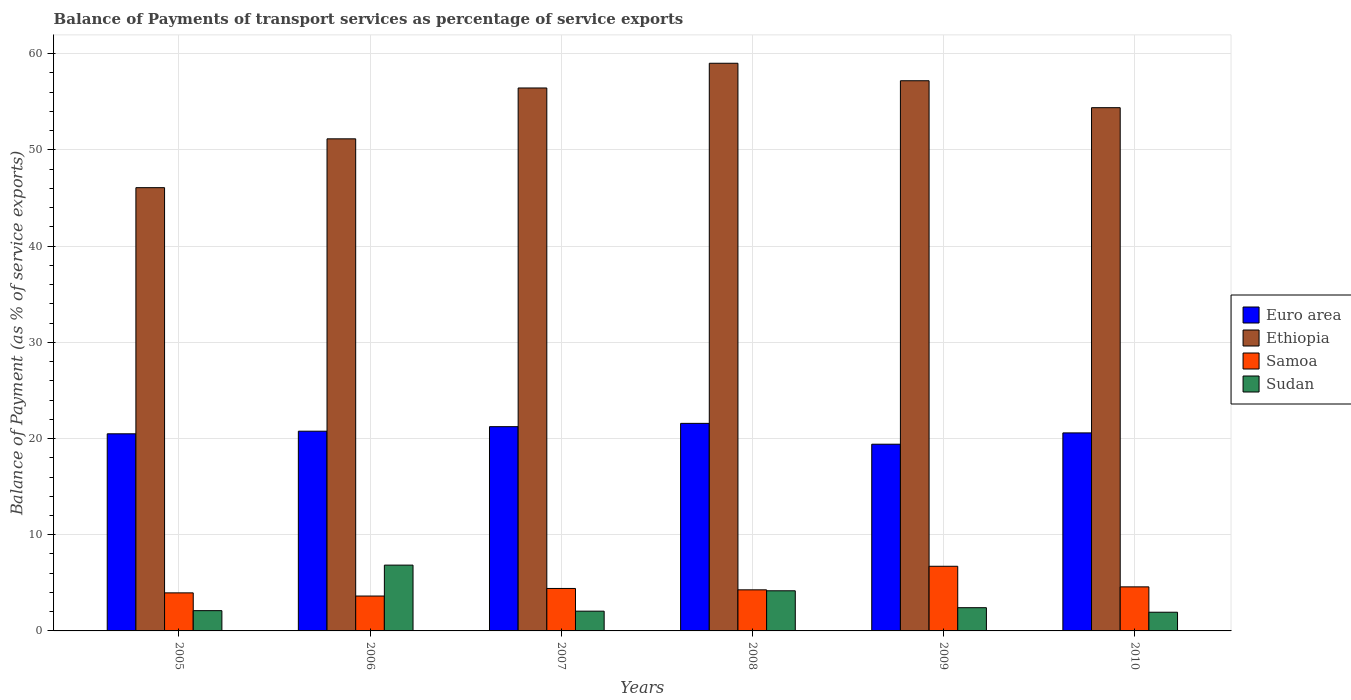Are the number of bars per tick equal to the number of legend labels?
Make the answer very short. Yes. Are the number of bars on each tick of the X-axis equal?
Offer a terse response. Yes. How many bars are there on the 3rd tick from the left?
Provide a succinct answer. 4. How many bars are there on the 1st tick from the right?
Offer a very short reply. 4. What is the label of the 2nd group of bars from the left?
Provide a short and direct response. 2006. What is the balance of payments of transport services in Sudan in 2010?
Your answer should be very brief. 1.94. Across all years, what is the maximum balance of payments of transport services in Sudan?
Provide a succinct answer. 6.84. Across all years, what is the minimum balance of payments of transport services in Ethiopia?
Your answer should be very brief. 46.08. What is the total balance of payments of transport services in Sudan in the graph?
Provide a succinct answer. 19.53. What is the difference between the balance of payments of transport services in Samoa in 2005 and that in 2009?
Give a very brief answer. -2.76. What is the difference between the balance of payments of transport services in Euro area in 2010 and the balance of payments of transport services in Samoa in 2005?
Make the answer very short. 16.63. What is the average balance of payments of transport services in Sudan per year?
Your answer should be compact. 3.26. In the year 2009, what is the difference between the balance of payments of transport services in Samoa and balance of payments of transport services in Ethiopia?
Your response must be concise. -50.47. In how many years, is the balance of payments of transport services in Samoa greater than 58 %?
Provide a short and direct response. 0. What is the ratio of the balance of payments of transport services in Euro area in 2006 to that in 2010?
Ensure brevity in your answer.  1.01. Is the difference between the balance of payments of transport services in Samoa in 2005 and 2009 greater than the difference between the balance of payments of transport services in Ethiopia in 2005 and 2009?
Provide a succinct answer. Yes. What is the difference between the highest and the second highest balance of payments of transport services in Euro area?
Your answer should be compact. 0.34. What is the difference between the highest and the lowest balance of payments of transport services in Samoa?
Provide a succinct answer. 3.09. Is it the case that in every year, the sum of the balance of payments of transport services in Ethiopia and balance of payments of transport services in Euro area is greater than the sum of balance of payments of transport services in Samoa and balance of payments of transport services in Sudan?
Offer a very short reply. No. What does the 1st bar from the left in 2007 represents?
Your answer should be compact. Euro area. What does the 3rd bar from the right in 2007 represents?
Give a very brief answer. Ethiopia. Is it the case that in every year, the sum of the balance of payments of transport services in Samoa and balance of payments of transport services in Sudan is greater than the balance of payments of transport services in Ethiopia?
Your response must be concise. No. Are all the bars in the graph horizontal?
Offer a terse response. No. How many years are there in the graph?
Your response must be concise. 6. Does the graph contain grids?
Give a very brief answer. Yes. Where does the legend appear in the graph?
Your answer should be very brief. Center right. How many legend labels are there?
Give a very brief answer. 4. What is the title of the graph?
Offer a very short reply. Balance of Payments of transport services as percentage of service exports. Does "Somalia" appear as one of the legend labels in the graph?
Provide a short and direct response. No. What is the label or title of the X-axis?
Make the answer very short. Years. What is the label or title of the Y-axis?
Provide a short and direct response. Balance of Payment (as % of service exports). What is the Balance of Payment (as % of service exports) of Euro area in 2005?
Offer a very short reply. 20.49. What is the Balance of Payment (as % of service exports) in Ethiopia in 2005?
Offer a terse response. 46.08. What is the Balance of Payment (as % of service exports) in Samoa in 2005?
Offer a very short reply. 3.96. What is the Balance of Payment (as % of service exports) in Sudan in 2005?
Provide a succinct answer. 2.11. What is the Balance of Payment (as % of service exports) in Euro area in 2006?
Make the answer very short. 20.76. What is the Balance of Payment (as % of service exports) in Ethiopia in 2006?
Give a very brief answer. 51.16. What is the Balance of Payment (as % of service exports) of Samoa in 2006?
Give a very brief answer. 3.63. What is the Balance of Payment (as % of service exports) of Sudan in 2006?
Offer a very short reply. 6.84. What is the Balance of Payment (as % of service exports) of Euro area in 2007?
Provide a succinct answer. 21.23. What is the Balance of Payment (as % of service exports) in Ethiopia in 2007?
Keep it short and to the point. 56.44. What is the Balance of Payment (as % of service exports) of Samoa in 2007?
Your response must be concise. 4.41. What is the Balance of Payment (as % of service exports) in Sudan in 2007?
Offer a terse response. 2.05. What is the Balance of Payment (as % of service exports) in Euro area in 2008?
Offer a terse response. 21.58. What is the Balance of Payment (as % of service exports) in Ethiopia in 2008?
Provide a short and direct response. 59.01. What is the Balance of Payment (as % of service exports) in Samoa in 2008?
Keep it short and to the point. 4.27. What is the Balance of Payment (as % of service exports) in Sudan in 2008?
Your answer should be very brief. 4.17. What is the Balance of Payment (as % of service exports) of Euro area in 2009?
Offer a very short reply. 19.41. What is the Balance of Payment (as % of service exports) of Ethiopia in 2009?
Make the answer very short. 57.19. What is the Balance of Payment (as % of service exports) in Samoa in 2009?
Your answer should be very brief. 6.72. What is the Balance of Payment (as % of service exports) in Sudan in 2009?
Give a very brief answer. 2.41. What is the Balance of Payment (as % of service exports) of Euro area in 2010?
Your answer should be very brief. 20.59. What is the Balance of Payment (as % of service exports) in Ethiopia in 2010?
Provide a succinct answer. 54.39. What is the Balance of Payment (as % of service exports) of Samoa in 2010?
Provide a succinct answer. 4.58. What is the Balance of Payment (as % of service exports) of Sudan in 2010?
Offer a very short reply. 1.94. Across all years, what is the maximum Balance of Payment (as % of service exports) of Euro area?
Offer a very short reply. 21.58. Across all years, what is the maximum Balance of Payment (as % of service exports) of Ethiopia?
Make the answer very short. 59.01. Across all years, what is the maximum Balance of Payment (as % of service exports) in Samoa?
Give a very brief answer. 6.72. Across all years, what is the maximum Balance of Payment (as % of service exports) in Sudan?
Offer a terse response. 6.84. Across all years, what is the minimum Balance of Payment (as % of service exports) of Euro area?
Make the answer very short. 19.41. Across all years, what is the minimum Balance of Payment (as % of service exports) in Ethiopia?
Keep it short and to the point. 46.08. Across all years, what is the minimum Balance of Payment (as % of service exports) of Samoa?
Offer a terse response. 3.63. Across all years, what is the minimum Balance of Payment (as % of service exports) in Sudan?
Your answer should be compact. 1.94. What is the total Balance of Payment (as % of service exports) in Euro area in the graph?
Your answer should be compact. 124.06. What is the total Balance of Payment (as % of service exports) of Ethiopia in the graph?
Provide a succinct answer. 324.28. What is the total Balance of Payment (as % of service exports) in Samoa in the graph?
Keep it short and to the point. 27.57. What is the total Balance of Payment (as % of service exports) of Sudan in the graph?
Give a very brief answer. 19.53. What is the difference between the Balance of Payment (as % of service exports) in Euro area in 2005 and that in 2006?
Offer a terse response. -0.27. What is the difference between the Balance of Payment (as % of service exports) in Ethiopia in 2005 and that in 2006?
Ensure brevity in your answer.  -5.08. What is the difference between the Balance of Payment (as % of service exports) in Samoa in 2005 and that in 2006?
Offer a terse response. 0.33. What is the difference between the Balance of Payment (as % of service exports) of Sudan in 2005 and that in 2006?
Offer a terse response. -4.73. What is the difference between the Balance of Payment (as % of service exports) in Euro area in 2005 and that in 2007?
Your response must be concise. -0.74. What is the difference between the Balance of Payment (as % of service exports) in Ethiopia in 2005 and that in 2007?
Provide a short and direct response. -10.36. What is the difference between the Balance of Payment (as % of service exports) of Samoa in 2005 and that in 2007?
Your response must be concise. -0.46. What is the difference between the Balance of Payment (as % of service exports) of Sudan in 2005 and that in 2007?
Provide a succinct answer. 0.05. What is the difference between the Balance of Payment (as % of service exports) in Euro area in 2005 and that in 2008?
Give a very brief answer. -1.09. What is the difference between the Balance of Payment (as % of service exports) of Ethiopia in 2005 and that in 2008?
Provide a succinct answer. -12.93. What is the difference between the Balance of Payment (as % of service exports) of Samoa in 2005 and that in 2008?
Give a very brief answer. -0.32. What is the difference between the Balance of Payment (as % of service exports) in Sudan in 2005 and that in 2008?
Provide a short and direct response. -2.07. What is the difference between the Balance of Payment (as % of service exports) in Euro area in 2005 and that in 2009?
Your answer should be compact. 1.08. What is the difference between the Balance of Payment (as % of service exports) of Ethiopia in 2005 and that in 2009?
Your answer should be compact. -11.12. What is the difference between the Balance of Payment (as % of service exports) in Samoa in 2005 and that in 2009?
Your response must be concise. -2.76. What is the difference between the Balance of Payment (as % of service exports) of Sudan in 2005 and that in 2009?
Your answer should be very brief. -0.31. What is the difference between the Balance of Payment (as % of service exports) of Euro area in 2005 and that in 2010?
Provide a short and direct response. -0.09. What is the difference between the Balance of Payment (as % of service exports) in Ethiopia in 2005 and that in 2010?
Provide a succinct answer. -8.31. What is the difference between the Balance of Payment (as % of service exports) of Samoa in 2005 and that in 2010?
Your answer should be very brief. -0.62. What is the difference between the Balance of Payment (as % of service exports) in Sudan in 2005 and that in 2010?
Provide a succinct answer. 0.16. What is the difference between the Balance of Payment (as % of service exports) in Euro area in 2006 and that in 2007?
Offer a terse response. -0.47. What is the difference between the Balance of Payment (as % of service exports) in Ethiopia in 2006 and that in 2007?
Ensure brevity in your answer.  -5.29. What is the difference between the Balance of Payment (as % of service exports) of Samoa in 2006 and that in 2007?
Your response must be concise. -0.79. What is the difference between the Balance of Payment (as % of service exports) of Sudan in 2006 and that in 2007?
Offer a very short reply. 4.79. What is the difference between the Balance of Payment (as % of service exports) of Euro area in 2006 and that in 2008?
Give a very brief answer. -0.81. What is the difference between the Balance of Payment (as % of service exports) in Ethiopia in 2006 and that in 2008?
Keep it short and to the point. -7.86. What is the difference between the Balance of Payment (as % of service exports) in Samoa in 2006 and that in 2008?
Provide a short and direct response. -0.65. What is the difference between the Balance of Payment (as % of service exports) in Sudan in 2006 and that in 2008?
Provide a succinct answer. 2.67. What is the difference between the Balance of Payment (as % of service exports) in Euro area in 2006 and that in 2009?
Make the answer very short. 1.35. What is the difference between the Balance of Payment (as % of service exports) of Ethiopia in 2006 and that in 2009?
Your answer should be very brief. -6.04. What is the difference between the Balance of Payment (as % of service exports) of Samoa in 2006 and that in 2009?
Your response must be concise. -3.09. What is the difference between the Balance of Payment (as % of service exports) in Sudan in 2006 and that in 2009?
Keep it short and to the point. 4.43. What is the difference between the Balance of Payment (as % of service exports) of Euro area in 2006 and that in 2010?
Provide a short and direct response. 0.18. What is the difference between the Balance of Payment (as % of service exports) in Ethiopia in 2006 and that in 2010?
Provide a short and direct response. -3.24. What is the difference between the Balance of Payment (as % of service exports) in Samoa in 2006 and that in 2010?
Provide a succinct answer. -0.95. What is the difference between the Balance of Payment (as % of service exports) in Sudan in 2006 and that in 2010?
Provide a short and direct response. 4.9. What is the difference between the Balance of Payment (as % of service exports) of Euro area in 2007 and that in 2008?
Ensure brevity in your answer.  -0.34. What is the difference between the Balance of Payment (as % of service exports) in Ethiopia in 2007 and that in 2008?
Offer a very short reply. -2.57. What is the difference between the Balance of Payment (as % of service exports) of Samoa in 2007 and that in 2008?
Provide a short and direct response. 0.14. What is the difference between the Balance of Payment (as % of service exports) of Sudan in 2007 and that in 2008?
Your answer should be very brief. -2.12. What is the difference between the Balance of Payment (as % of service exports) of Euro area in 2007 and that in 2009?
Provide a succinct answer. 1.82. What is the difference between the Balance of Payment (as % of service exports) in Ethiopia in 2007 and that in 2009?
Provide a short and direct response. -0.75. What is the difference between the Balance of Payment (as % of service exports) in Samoa in 2007 and that in 2009?
Provide a succinct answer. -2.31. What is the difference between the Balance of Payment (as % of service exports) of Sudan in 2007 and that in 2009?
Offer a very short reply. -0.36. What is the difference between the Balance of Payment (as % of service exports) in Euro area in 2007 and that in 2010?
Make the answer very short. 0.65. What is the difference between the Balance of Payment (as % of service exports) of Ethiopia in 2007 and that in 2010?
Ensure brevity in your answer.  2.05. What is the difference between the Balance of Payment (as % of service exports) of Samoa in 2007 and that in 2010?
Provide a short and direct response. -0.17. What is the difference between the Balance of Payment (as % of service exports) in Sudan in 2007 and that in 2010?
Keep it short and to the point. 0.11. What is the difference between the Balance of Payment (as % of service exports) of Euro area in 2008 and that in 2009?
Provide a succinct answer. 2.17. What is the difference between the Balance of Payment (as % of service exports) in Ethiopia in 2008 and that in 2009?
Keep it short and to the point. 1.82. What is the difference between the Balance of Payment (as % of service exports) in Samoa in 2008 and that in 2009?
Keep it short and to the point. -2.45. What is the difference between the Balance of Payment (as % of service exports) of Sudan in 2008 and that in 2009?
Offer a very short reply. 1.76. What is the difference between the Balance of Payment (as % of service exports) in Euro area in 2008 and that in 2010?
Offer a terse response. 0.99. What is the difference between the Balance of Payment (as % of service exports) in Ethiopia in 2008 and that in 2010?
Your answer should be very brief. 4.62. What is the difference between the Balance of Payment (as % of service exports) in Samoa in 2008 and that in 2010?
Give a very brief answer. -0.31. What is the difference between the Balance of Payment (as % of service exports) in Sudan in 2008 and that in 2010?
Your answer should be compact. 2.23. What is the difference between the Balance of Payment (as % of service exports) in Euro area in 2009 and that in 2010?
Your answer should be very brief. -1.18. What is the difference between the Balance of Payment (as % of service exports) of Ethiopia in 2009 and that in 2010?
Ensure brevity in your answer.  2.8. What is the difference between the Balance of Payment (as % of service exports) of Samoa in 2009 and that in 2010?
Your response must be concise. 2.14. What is the difference between the Balance of Payment (as % of service exports) of Sudan in 2009 and that in 2010?
Make the answer very short. 0.47. What is the difference between the Balance of Payment (as % of service exports) in Euro area in 2005 and the Balance of Payment (as % of service exports) in Ethiopia in 2006?
Offer a terse response. -30.66. What is the difference between the Balance of Payment (as % of service exports) in Euro area in 2005 and the Balance of Payment (as % of service exports) in Samoa in 2006?
Provide a short and direct response. 16.87. What is the difference between the Balance of Payment (as % of service exports) of Euro area in 2005 and the Balance of Payment (as % of service exports) of Sudan in 2006?
Your response must be concise. 13.65. What is the difference between the Balance of Payment (as % of service exports) of Ethiopia in 2005 and the Balance of Payment (as % of service exports) of Samoa in 2006?
Ensure brevity in your answer.  42.45. What is the difference between the Balance of Payment (as % of service exports) of Ethiopia in 2005 and the Balance of Payment (as % of service exports) of Sudan in 2006?
Offer a very short reply. 39.24. What is the difference between the Balance of Payment (as % of service exports) of Samoa in 2005 and the Balance of Payment (as % of service exports) of Sudan in 2006?
Make the answer very short. -2.88. What is the difference between the Balance of Payment (as % of service exports) of Euro area in 2005 and the Balance of Payment (as % of service exports) of Ethiopia in 2007?
Your answer should be very brief. -35.95. What is the difference between the Balance of Payment (as % of service exports) of Euro area in 2005 and the Balance of Payment (as % of service exports) of Samoa in 2007?
Offer a very short reply. 16.08. What is the difference between the Balance of Payment (as % of service exports) in Euro area in 2005 and the Balance of Payment (as % of service exports) in Sudan in 2007?
Your response must be concise. 18.44. What is the difference between the Balance of Payment (as % of service exports) of Ethiopia in 2005 and the Balance of Payment (as % of service exports) of Samoa in 2007?
Provide a short and direct response. 41.67. What is the difference between the Balance of Payment (as % of service exports) of Ethiopia in 2005 and the Balance of Payment (as % of service exports) of Sudan in 2007?
Your response must be concise. 44.03. What is the difference between the Balance of Payment (as % of service exports) in Samoa in 2005 and the Balance of Payment (as % of service exports) in Sudan in 2007?
Offer a terse response. 1.9. What is the difference between the Balance of Payment (as % of service exports) in Euro area in 2005 and the Balance of Payment (as % of service exports) in Ethiopia in 2008?
Keep it short and to the point. -38.52. What is the difference between the Balance of Payment (as % of service exports) of Euro area in 2005 and the Balance of Payment (as % of service exports) of Samoa in 2008?
Keep it short and to the point. 16.22. What is the difference between the Balance of Payment (as % of service exports) in Euro area in 2005 and the Balance of Payment (as % of service exports) in Sudan in 2008?
Your response must be concise. 16.32. What is the difference between the Balance of Payment (as % of service exports) of Ethiopia in 2005 and the Balance of Payment (as % of service exports) of Samoa in 2008?
Make the answer very short. 41.81. What is the difference between the Balance of Payment (as % of service exports) of Ethiopia in 2005 and the Balance of Payment (as % of service exports) of Sudan in 2008?
Make the answer very short. 41.91. What is the difference between the Balance of Payment (as % of service exports) of Samoa in 2005 and the Balance of Payment (as % of service exports) of Sudan in 2008?
Your answer should be compact. -0.22. What is the difference between the Balance of Payment (as % of service exports) of Euro area in 2005 and the Balance of Payment (as % of service exports) of Ethiopia in 2009?
Make the answer very short. -36.7. What is the difference between the Balance of Payment (as % of service exports) in Euro area in 2005 and the Balance of Payment (as % of service exports) in Samoa in 2009?
Keep it short and to the point. 13.77. What is the difference between the Balance of Payment (as % of service exports) in Euro area in 2005 and the Balance of Payment (as % of service exports) in Sudan in 2009?
Ensure brevity in your answer.  18.08. What is the difference between the Balance of Payment (as % of service exports) of Ethiopia in 2005 and the Balance of Payment (as % of service exports) of Samoa in 2009?
Provide a short and direct response. 39.36. What is the difference between the Balance of Payment (as % of service exports) of Ethiopia in 2005 and the Balance of Payment (as % of service exports) of Sudan in 2009?
Ensure brevity in your answer.  43.66. What is the difference between the Balance of Payment (as % of service exports) in Samoa in 2005 and the Balance of Payment (as % of service exports) in Sudan in 2009?
Provide a short and direct response. 1.54. What is the difference between the Balance of Payment (as % of service exports) in Euro area in 2005 and the Balance of Payment (as % of service exports) in Ethiopia in 2010?
Give a very brief answer. -33.9. What is the difference between the Balance of Payment (as % of service exports) in Euro area in 2005 and the Balance of Payment (as % of service exports) in Samoa in 2010?
Offer a very short reply. 15.91. What is the difference between the Balance of Payment (as % of service exports) of Euro area in 2005 and the Balance of Payment (as % of service exports) of Sudan in 2010?
Give a very brief answer. 18.55. What is the difference between the Balance of Payment (as % of service exports) in Ethiopia in 2005 and the Balance of Payment (as % of service exports) in Samoa in 2010?
Provide a short and direct response. 41.5. What is the difference between the Balance of Payment (as % of service exports) in Ethiopia in 2005 and the Balance of Payment (as % of service exports) in Sudan in 2010?
Make the answer very short. 44.14. What is the difference between the Balance of Payment (as % of service exports) of Samoa in 2005 and the Balance of Payment (as % of service exports) of Sudan in 2010?
Provide a short and direct response. 2.01. What is the difference between the Balance of Payment (as % of service exports) in Euro area in 2006 and the Balance of Payment (as % of service exports) in Ethiopia in 2007?
Make the answer very short. -35.68. What is the difference between the Balance of Payment (as % of service exports) in Euro area in 2006 and the Balance of Payment (as % of service exports) in Samoa in 2007?
Give a very brief answer. 16.35. What is the difference between the Balance of Payment (as % of service exports) in Euro area in 2006 and the Balance of Payment (as % of service exports) in Sudan in 2007?
Ensure brevity in your answer.  18.71. What is the difference between the Balance of Payment (as % of service exports) of Ethiopia in 2006 and the Balance of Payment (as % of service exports) of Samoa in 2007?
Make the answer very short. 46.74. What is the difference between the Balance of Payment (as % of service exports) in Ethiopia in 2006 and the Balance of Payment (as % of service exports) in Sudan in 2007?
Offer a terse response. 49.1. What is the difference between the Balance of Payment (as % of service exports) in Samoa in 2006 and the Balance of Payment (as % of service exports) in Sudan in 2007?
Your answer should be compact. 1.57. What is the difference between the Balance of Payment (as % of service exports) of Euro area in 2006 and the Balance of Payment (as % of service exports) of Ethiopia in 2008?
Make the answer very short. -38.25. What is the difference between the Balance of Payment (as % of service exports) of Euro area in 2006 and the Balance of Payment (as % of service exports) of Samoa in 2008?
Your answer should be very brief. 16.49. What is the difference between the Balance of Payment (as % of service exports) of Euro area in 2006 and the Balance of Payment (as % of service exports) of Sudan in 2008?
Your answer should be very brief. 16.59. What is the difference between the Balance of Payment (as % of service exports) of Ethiopia in 2006 and the Balance of Payment (as % of service exports) of Samoa in 2008?
Ensure brevity in your answer.  46.88. What is the difference between the Balance of Payment (as % of service exports) in Ethiopia in 2006 and the Balance of Payment (as % of service exports) in Sudan in 2008?
Make the answer very short. 46.98. What is the difference between the Balance of Payment (as % of service exports) of Samoa in 2006 and the Balance of Payment (as % of service exports) of Sudan in 2008?
Ensure brevity in your answer.  -0.55. What is the difference between the Balance of Payment (as % of service exports) of Euro area in 2006 and the Balance of Payment (as % of service exports) of Ethiopia in 2009?
Make the answer very short. -36.43. What is the difference between the Balance of Payment (as % of service exports) in Euro area in 2006 and the Balance of Payment (as % of service exports) in Samoa in 2009?
Provide a succinct answer. 14.04. What is the difference between the Balance of Payment (as % of service exports) of Euro area in 2006 and the Balance of Payment (as % of service exports) of Sudan in 2009?
Give a very brief answer. 18.35. What is the difference between the Balance of Payment (as % of service exports) of Ethiopia in 2006 and the Balance of Payment (as % of service exports) of Samoa in 2009?
Your answer should be compact. 44.44. What is the difference between the Balance of Payment (as % of service exports) in Ethiopia in 2006 and the Balance of Payment (as % of service exports) in Sudan in 2009?
Give a very brief answer. 48.74. What is the difference between the Balance of Payment (as % of service exports) of Samoa in 2006 and the Balance of Payment (as % of service exports) of Sudan in 2009?
Give a very brief answer. 1.21. What is the difference between the Balance of Payment (as % of service exports) in Euro area in 2006 and the Balance of Payment (as % of service exports) in Ethiopia in 2010?
Make the answer very short. -33.63. What is the difference between the Balance of Payment (as % of service exports) in Euro area in 2006 and the Balance of Payment (as % of service exports) in Samoa in 2010?
Your response must be concise. 16.18. What is the difference between the Balance of Payment (as % of service exports) in Euro area in 2006 and the Balance of Payment (as % of service exports) in Sudan in 2010?
Make the answer very short. 18.82. What is the difference between the Balance of Payment (as % of service exports) in Ethiopia in 2006 and the Balance of Payment (as % of service exports) in Samoa in 2010?
Your answer should be very brief. 46.58. What is the difference between the Balance of Payment (as % of service exports) of Ethiopia in 2006 and the Balance of Payment (as % of service exports) of Sudan in 2010?
Ensure brevity in your answer.  49.21. What is the difference between the Balance of Payment (as % of service exports) of Samoa in 2006 and the Balance of Payment (as % of service exports) of Sudan in 2010?
Offer a terse response. 1.68. What is the difference between the Balance of Payment (as % of service exports) of Euro area in 2007 and the Balance of Payment (as % of service exports) of Ethiopia in 2008?
Your answer should be very brief. -37.78. What is the difference between the Balance of Payment (as % of service exports) in Euro area in 2007 and the Balance of Payment (as % of service exports) in Samoa in 2008?
Make the answer very short. 16.96. What is the difference between the Balance of Payment (as % of service exports) in Euro area in 2007 and the Balance of Payment (as % of service exports) in Sudan in 2008?
Keep it short and to the point. 17.06. What is the difference between the Balance of Payment (as % of service exports) of Ethiopia in 2007 and the Balance of Payment (as % of service exports) of Samoa in 2008?
Provide a short and direct response. 52.17. What is the difference between the Balance of Payment (as % of service exports) of Ethiopia in 2007 and the Balance of Payment (as % of service exports) of Sudan in 2008?
Provide a succinct answer. 52.27. What is the difference between the Balance of Payment (as % of service exports) of Samoa in 2007 and the Balance of Payment (as % of service exports) of Sudan in 2008?
Your answer should be compact. 0.24. What is the difference between the Balance of Payment (as % of service exports) in Euro area in 2007 and the Balance of Payment (as % of service exports) in Ethiopia in 2009?
Your answer should be compact. -35.96. What is the difference between the Balance of Payment (as % of service exports) in Euro area in 2007 and the Balance of Payment (as % of service exports) in Samoa in 2009?
Provide a succinct answer. 14.51. What is the difference between the Balance of Payment (as % of service exports) in Euro area in 2007 and the Balance of Payment (as % of service exports) in Sudan in 2009?
Offer a very short reply. 18.82. What is the difference between the Balance of Payment (as % of service exports) in Ethiopia in 2007 and the Balance of Payment (as % of service exports) in Samoa in 2009?
Provide a short and direct response. 49.72. What is the difference between the Balance of Payment (as % of service exports) in Ethiopia in 2007 and the Balance of Payment (as % of service exports) in Sudan in 2009?
Keep it short and to the point. 54.03. What is the difference between the Balance of Payment (as % of service exports) of Samoa in 2007 and the Balance of Payment (as % of service exports) of Sudan in 2009?
Provide a short and direct response. 2. What is the difference between the Balance of Payment (as % of service exports) in Euro area in 2007 and the Balance of Payment (as % of service exports) in Ethiopia in 2010?
Make the answer very short. -33.16. What is the difference between the Balance of Payment (as % of service exports) in Euro area in 2007 and the Balance of Payment (as % of service exports) in Samoa in 2010?
Ensure brevity in your answer.  16.65. What is the difference between the Balance of Payment (as % of service exports) in Euro area in 2007 and the Balance of Payment (as % of service exports) in Sudan in 2010?
Offer a very short reply. 19.29. What is the difference between the Balance of Payment (as % of service exports) in Ethiopia in 2007 and the Balance of Payment (as % of service exports) in Samoa in 2010?
Keep it short and to the point. 51.86. What is the difference between the Balance of Payment (as % of service exports) in Ethiopia in 2007 and the Balance of Payment (as % of service exports) in Sudan in 2010?
Your answer should be compact. 54.5. What is the difference between the Balance of Payment (as % of service exports) in Samoa in 2007 and the Balance of Payment (as % of service exports) in Sudan in 2010?
Keep it short and to the point. 2.47. What is the difference between the Balance of Payment (as % of service exports) of Euro area in 2008 and the Balance of Payment (as % of service exports) of Ethiopia in 2009?
Offer a terse response. -35.62. What is the difference between the Balance of Payment (as % of service exports) of Euro area in 2008 and the Balance of Payment (as % of service exports) of Samoa in 2009?
Your response must be concise. 14.86. What is the difference between the Balance of Payment (as % of service exports) of Euro area in 2008 and the Balance of Payment (as % of service exports) of Sudan in 2009?
Your answer should be compact. 19.16. What is the difference between the Balance of Payment (as % of service exports) in Ethiopia in 2008 and the Balance of Payment (as % of service exports) in Samoa in 2009?
Ensure brevity in your answer.  52.29. What is the difference between the Balance of Payment (as % of service exports) of Ethiopia in 2008 and the Balance of Payment (as % of service exports) of Sudan in 2009?
Offer a terse response. 56.6. What is the difference between the Balance of Payment (as % of service exports) in Samoa in 2008 and the Balance of Payment (as % of service exports) in Sudan in 2009?
Provide a short and direct response. 1.86. What is the difference between the Balance of Payment (as % of service exports) in Euro area in 2008 and the Balance of Payment (as % of service exports) in Ethiopia in 2010?
Your answer should be very brief. -32.82. What is the difference between the Balance of Payment (as % of service exports) in Euro area in 2008 and the Balance of Payment (as % of service exports) in Samoa in 2010?
Keep it short and to the point. 17. What is the difference between the Balance of Payment (as % of service exports) in Euro area in 2008 and the Balance of Payment (as % of service exports) in Sudan in 2010?
Make the answer very short. 19.63. What is the difference between the Balance of Payment (as % of service exports) of Ethiopia in 2008 and the Balance of Payment (as % of service exports) of Samoa in 2010?
Keep it short and to the point. 54.43. What is the difference between the Balance of Payment (as % of service exports) in Ethiopia in 2008 and the Balance of Payment (as % of service exports) in Sudan in 2010?
Offer a very short reply. 57.07. What is the difference between the Balance of Payment (as % of service exports) in Samoa in 2008 and the Balance of Payment (as % of service exports) in Sudan in 2010?
Offer a terse response. 2.33. What is the difference between the Balance of Payment (as % of service exports) in Euro area in 2009 and the Balance of Payment (as % of service exports) in Ethiopia in 2010?
Offer a very short reply. -34.98. What is the difference between the Balance of Payment (as % of service exports) of Euro area in 2009 and the Balance of Payment (as % of service exports) of Samoa in 2010?
Provide a short and direct response. 14.83. What is the difference between the Balance of Payment (as % of service exports) in Euro area in 2009 and the Balance of Payment (as % of service exports) in Sudan in 2010?
Keep it short and to the point. 17.47. What is the difference between the Balance of Payment (as % of service exports) of Ethiopia in 2009 and the Balance of Payment (as % of service exports) of Samoa in 2010?
Provide a succinct answer. 52.61. What is the difference between the Balance of Payment (as % of service exports) in Ethiopia in 2009 and the Balance of Payment (as % of service exports) in Sudan in 2010?
Make the answer very short. 55.25. What is the difference between the Balance of Payment (as % of service exports) in Samoa in 2009 and the Balance of Payment (as % of service exports) in Sudan in 2010?
Your answer should be compact. 4.78. What is the average Balance of Payment (as % of service exports) of Euro area per year?
Your answer should be very brief. 20.68. What is the average Balance of Payment (as % of service exports) of Ethiopia per year?
Give a very brief answer. 54.05. What is the average Balance of Payment (as % of service exports) of Samoa per year?
Offer a terse response. 4.59. What is the average Balance of Payment (as % of service exports) of Sudan per year?
Offer a very short reply. 3.26. In the year 2005, what is the difference between the Balance of Payment (as % of service exports) in Euro area and Balance of Payment (as % of service exports) in Ethiopia?
Make the answer very short. -25.59. In the year 2005, what is the difference between the Balance of Payment (as % of service exports) in Euro area and Balance of Payment (as % of service exports) in Samoa?
Provide a short and direct response. 16.54. In the year 2005, what is the difference between the Balance of Payment (as % of service exports) of Euro area and Balance of Payment (as % of service exports) of Sudan?
Ensure brevity in your answer.  18.38. In the year 2005, what is the difference between the Balance of Payment (as % of service exports) in Ethiopia and Balance of Payment (as % of service exports) in Samoa?
Your answer should be very brief. 42.12. In the year 2005, what is the difference between the Balance of Payment (as % of service exports) in Ethiopia and Balance of Payment (as % of service exports) in Sudan?
Provide a succinct answer. 43.97. In the year 2005, what is the difference between the Balance of Payment (as % of service exports) of Samoa and Balance of Payment (as % of service exports) of Sudan?
Offer a terse response. 1.85. In the year 2006, what is the difference between the Balance of Payment (as % of service exports) in Euro area and Balance of Payment (as % of service exports) in Ethiopia?
Your answer should be very brief. -30.39. In the year 2006, what is the difference between the Balance of Payment (as % of service exports) of Euro area and Balance of Payment (as % of service exports) of Samoa?
Provide a short and direct response. 17.14. In the year 2006, what is the difference between the Balance of Payment (as % of service exports) of Euro area and Balance of Payment (as % of service exports) of Sudan?
Offer a very short reply. 13.92. In the year 2006, what is the difference between the Balance of Payment (as % of service exports) in Ethiopia and Balance of Payment (as % of service exports) in Samoa?
Provide a succinct answer. 47.53. In the year 2006, what is the difference between the Balance of Payment (as % of service exports) of Ethiopia and Balance of Payment (as % of service exports) of Sudan?
Keep it short and to the point. 44.32. In the year 2006, what is the difference between the Balance of Payment (as % of service exports) of Samoa and Balance of Payment (as % of service exports) of Sudan?
Give a very brief answer. -3.21. In the year 2007, what is the difference between the Balance of Payment (as % of service exports) of Euro area and Balance of Payment (as % of service exports) of Ethiopia?
Make the answer very short. -35.21. In the year 2007, what is the difference between the Balance of Payment (as % of service exports) in Euro area and Balance of Payment (as % of service exports) in Samoa?
Ensure brevity in your answer.  16.82. In the year 2007, what is the difference between the Balance of Payment (as % of service exports) in Euro area and Balance of Payment (as % of service exports) in Sudan?
Offer a terse response. 19.18. In the year 2007, what is the difference between the Balance of Payment (as % of service exports) in Ethiopia and Balance of Payment (as % of service exports) in Samoa?
Give a very brief answer. 52.03. In the year 2007, what is the difference between the Balance of Payment (as % of service exports) of Ethiopia and Balance of Payment (as % of service exports) of Sudan?
Your answer should be very brief. 54.39. In the year 2007, what is the difference between the Balance of Payment (as % of service exports) in Samoa and Balance of Payment (as % of service exports) in Sudan?
Your answer should be very brief. 2.36. In the year 2008, what is the difference between the Balance of Payment (as % of service exports) of Euro area and Balance of Payment (as % of service exports) of Ethiopia?
Your answer should be compact. -37.44. In the year 2008, what is the difference between the Balance of Payment (as % of service exports) in Euro area and Balance of Payment (as % of service exports) in Samoa?
Make the answer very short. 17.31. In the year 2008, what is the difference between the Balance of Payment (as % of service exports) of Euro area and Balance of Payment (as % of service exports) of Sudan?
Keep it short and to the point. 17.4. In the year 2008, what is the difference between the Balance of Payment (as % of service exports) in Ethiopia and Balance of Payment (as % of service exports) in Samoa?
Offer a terse response. 54.74. In the year 2008, what is the difference between the Balance of Payment (as % of service exports) in Ethiopia and Balance of Payment (as % of service exports) in Sudan?
Offer a very short reply. 54.84. In the year 2008, what is the difference between the Balance of Payment (as % of service exports) in Samoa and Balance of Payment (as % of service exports) in Sudan?
Provide a short and direct response. 0.1. In the year 2009, what is the difference between the Balance of Payment (as % of service exports) in Euro area and Balance of Payment (as % of service exports) in Ethiopia?
Keep it short and to the point. -37.78. In the year 2009, what is the difference between the Balance of Payment (as % of service exports) of Euro area and Balance of Payment (as % of service exports) of Samoa?
Your answer should be compact. 12.69. In the year 2009, what is the difference between the Balance of Payment (as % of service exports) of Euro area and Balance of Payment (as % of service exports) of Sudan?
Provide a short and direct response. 17. In the year 2009, what is the difference between the Balance of Payment (as % of service exports) in Ethiopia and Balance of Payment (as % of service exports) in Samoa?
Give a very brief answer. 50.47. In the year 2009, what is the difference between the Balance of Payment (as % of service exports) in Ethiopia and Balance of Payment (as % of service exports) in Sudan?
Your response must be concise. 54.78. In the year 2009, what is the difference between the Balance of Payment (as % of service exports) in Samoa and Balance of Payment (as % of service exports) in Sudan?
Offer a very short reply. 4.3. In the year 2010, what is the difference between the Balance of Payment (as % of service exports) in Euro area and Balance of Payment (as % of service exports) in Ethiopia?
Offer a very short reply. -33.81. In the year 2010, what is the difference between the Balance of Payment (as % of service exports) in Euro area and Balance of Payment (as % of service exports) in Samoa?
Your answer should be very brief. 16.01. In the year 2010, what is the difference between the Balance of Payment (as % of service exports) of Euro area and Balance of Payment (as % of service exports) of Sudan?
Your answer should be compact. 18.64. In the year 2010, what is the difference between the Balance of Payment (as % of service exports) of Ethiopia and Balance of Payment (as % of service exports) of Samoa?
Your response must be concise. 49.81. In the year 2010, what is the difference between the Balance of Payment (as % of service exports) in Ethiopia and Balance of Payment (as % of service exports) in Sudan?
Offer a terse response. 52.45. In the year 2010, what is the difference between the Balance of Payment (as % of service exports) of Samoa and Balance of Payment (as % of service exports) of Sudan?
Your answer should be very brief. 2.64. What is the ratio of the Balance of Payment (as % of service exports) of Euro area in 2005 to that in 2006?
Make the answer very short. 0.99. What is the ratio of the Balance of Payment (as % of service exports) in Ethiopia in 2005 to that in 2006?
Your response must be concise. 0.9. What is the ratio of the Balance of Payment (as % of service exports) of Samoa in 2005 to that in 2006?
Make the answer very short. 1.09. What is the ratio of the Balance of Payment (as % of service exports) of Sudan in 2005 to that in 2006?
Provide a succinct answer. 0.31. What is the ratio of the Balance of Payment (as % of service exports) of Euro area in 2005 to that in 2007?
Provide a succinct answer. 0.96. What is the ratio of the Balance of Payment (as % of service exports) in Ethiopia in 2005 to that in 2007?
Your answer should be compact. 0.82. What is the ratio of the Balance of Payment (as % of service exports) of Samoa in 2005 to that in 2007?
Give a very brief answer. 0.9. What is the ratio of the Balance of Payment (as % of service exports) of Sudan in 2005 to that in 2007?
Your response must be concise. 1.03. What is the ratio of the Balance of Payment (as % of service exports) of Euro area in 2005 to that in 2008?
Provide a short and direct response. 0.95. What is the ratio of the Balance of Payment (as % of service exports) of Ethiopia in 2005 to that in 2008?
Your response must be concise. 0.78. What is the ratio of the Balance of Payment (as % of service exports) in Samoa in 2005 to that in 2008?
Ensure brevity in your answer.  0.93. What is the ratio of the Balance of Payment (as % of service exports) of Sudan in 2005 to that in 2008?
Offer a very short reply. 0.51. What is the ratio of the Balance of Payment (as % of service exports) of Euro area in 2005 to that in 2009?
Give a very brief answer. 1.06. What is the ratio of the Balance of Payment (as % of service exports) of Ethiopia in 2005 to that in 2009?
Provide a succinct answer. 0.81. What is the ratio of the Balance of Payment (as % of service exports) of Samoa in 2005 to that in 2009?
Provide a short and direct response. 0.59. What is the ratio of the Balance of Payment (as % of service exports) in Sudan in 2005 to that in 2009?
Provide a short and direct response. 0.87. What is the ratio of the Balance of Payment (as % of service exports) in Euro area in 2005 to that in 2010?
Give a very brief answer. 1. What is the ratio of the Balance of Payment (as % of service exports) of Ethiopia in 2005 to that in 2010?
Give a very brief answer. 0.85. What is the ratio of the Balance of Payment (as % of service exports) in Samoa in 2005 to that in 2010?
Your answer should be very brief. 0.86. What is the ratio of the Balance of Payment (as % of service exports) in Sudan in 2005 to that in 2010?
Make the answer very short. 1.08. What is the ratio of the Balance of Payment (as % of service exports) in Euro area in 2006 to that in 2007?
Provide a succinct answer. 0.98. What is the ratio of the Balance of Payment (as % of service exports) of Ethiopia in 2006 to that in 2007?
Provide a short and direct response. 0.91. What is the ratio of the Balance of Payment (as % of service exports) in Samoa in 2006 to that in 2007?
Your answer should be compact. 0.82. What is the ratio of the Balance of Payment (as % of service exports) in Sudan in 2006 to that in 2007?
Offer a terse response. 3.33. What is the ratio of the Balance of Payment (as % of service exports) of Euro area in 2006 to that in 2008?
Provide a succinct answer. 0.96. What is the ratio of the Balance of Payment (as % of service exports) in Ethiopia in 2006 to that in 2008?
Offer a terse response. 0.87. What is the ratio of the Balance of Payment (as % of service exports) of Samoa in 2006 to that in 2008?
Provide a short and direct response. 0.85. What is the ratio of the Balance of Payment (as % of service exports) of Sudan in 2006 to that in 2008?
Your response must be concise. 1.64. What is the ratio of the Balance of Payment (as % of service exports) in Euro area in 2006 to that in 2009?
Ensure brevity in your answer.  1.07. What is the ratio of the Balance of Payment (as % of service exports) in Ethiopia in 2006 to that in 2009?
Offer a terse response. 0.89. What is the ratio of the Balance of Payment (as % of service exports) in Samoa in 2006 to that in 2009?
Provide a succinct answer. 0.54. What is the ratio of the Balance of Payment (as % of service exports) of Sudan in 2006 to that in 2009?
Offer a very short reply. 2.83. What is the ratio of the Balance of Payment (as % of service exports) in Euro area in 2006 to that in 2010?
Keep it short and to the point. 1.01. What is the ratio of the Balance of Payment (as % of service exports) in Ethiopia in 2006 to that in 2010?
Your response must be concise. 0.94. What is the ratio of the Balance of Payment (as % of service exports) in Samoa in 2006 to that in 2010?
Offer a terse response. 0.79. What is the ratio of the Balance of Payment (as % of service exports) of Sudan in 2006 to that in 2010?
Ensure brevity in your answer.  3.52. What is the ratio of the Balance of Payment (as % of service exports) of Euro area in 2007 to that in 2008?
Your answer should be very brief. 0.98. What is the ratio of the Balance of Payment (as % of service exports) in Ethiopia in 2007 to that in 2008?
Your response must be concise. 0.96. What is the ratio of the Balance of Payment (as % of service exports) of Samoa in 2007 to that in 2008?
Ensure brevity in your answer.  1.03. What is the ratio of the Balance of Payment (as % of service exports) of Sudan in 2007 to that in 2008?
Your answer should be very brief. 0.49. What is the ratio of the Balance of Payment (as % of service exports) in Euro area in 2007 to that in 2009?
Your response must be concise. 1.09. What is the ratio of the Balance of Payment (as % of service exports) in Samoa in 2007 to that in 2009?
Offer a terse response. 0.66. What is the ratio of the Balance of Payment (as % of service exports) in Sudan in 2007 to that in 2009?
Provide a succinct answer. 0.85. What is the ratio of the Balance of Payment (as % of service exports) of Euro area in 2007 to that in 2010?
Your answer should be very brief. 1.03. What is the ratio of the Balance of Payment (as % of service exports) in Ethiopia in 2007 to that in 2010?
Provide a succinct answer. 1.04. What is the ratio of the Balance of Payment (as % of service exports) in Samoa in 2007 to that in 2010?
Provide a succinct answer. 0.96. What is the ratio of the Balance of Payment (as % of service exports) of Sudan in 2007 to that in 2010?
Your response must be concise. 1.06. What is the ratio of the Balance of Payment (as % of service exports) of Euro area in 2008 to that in 2009?
Give a very brief answer. 1.11. What is the ratio of the Balance of Payment (as % of service exports) of Ethiopia in 2008 to that in 2009?
Ensure brevity in your answer.  1.03. What is the ratio of the Balance of Payment (as % of service exports) of Samoa in 2008 to that in 2009?
Give a very brief answer. 0.64. What is the ratio of the Balance of Payment (as % of service exports) in Sudan in 2008 to that in 2009?
Keep it short and to the point. 1.73. What is the ratio of the Balance of Payment (as % of service exports) of Euro area in 2008 to that in 2010?
Offer a very short reply. 1.05. What is the ratio of the Balance of Payment (as % of service exports) of Ethiopia in 2008 to that in 2010?
Provide a short and direct response. 1.08. What is the ratio of the Balance of Payment (as % of service exports) in Samoa in 2008 to that in 2010?
Offer a terse response. 0.93. What is the ratio of the Balance of Payment (as % of service exports) of Sudan in 2008 to that in 2010?
Your answer should be compact. 2.15. What is the ratio of the Balance of Payment (as % of service exports) in Euro area in 2009 to that in 2010?
Keep it short and to the point. 0.94. What is the ratio of the Balance of Payment (as % of service exports) of Ethiopia in 2009 to that in 2010?
Provide a short and direct response. 1.05. What is the ratio of the Balance of Payment (as % of service exports) of Samoa in 2009 to that in 2010?
Keep it short and to the point. 1.47. What is the ratio of the Balance of Payment (as % of service exports) in Sudan in 2009 to that in 2010?
Offer a very short reply. 1.24. What is the difference between the highest and the second highest Balance of Payment (as % of service exports) in Euro area?
Give a very brief answer. 0.34. What is the difference between the highest and the second highest Balance of Payment (as % of service exports) of Ethiopia?
Offer a very short reply. 1.82. What is the difference between the highest and the second highest Balance of Payment (as % of service exports) in Samoa?
Give a very brief answer. 2.14. What is the difference between the highest and the second highest Balance of Payment (as % of service exports) in Sudan?
Ensure brevity in your answer.  2.67. What is the difference between the highest and the lowest Balance of Payment (as % of service exports) of Euro area?
Make the answer very short. 2.17. What is the difference between the highest and the lowest Balance of Payment (as % of service exports) in Ethiopia?
Ensure brevity in your answer.  12.93. What is the difference between the highest and the lowest Balance of Payment (as % of service exports) in Samoa?
Offer a very short reply. 3.09. What is the difference between the highest and the lowest Balance of Payment (as % of service exports) of Sudan?
Keep it short and to the point. 4.9. 